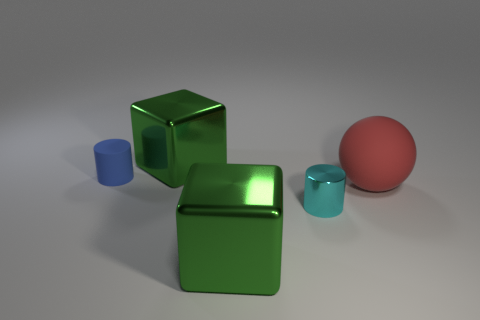Add 4 cyan metal cylinders. How many objects exist? 9 Subtract all cubes. How many objects are left? 3 Add 3 red spheres. How many red spheres exist? 4 Subtract 0 gray blocks. How many objects are left? 5 Subtract all green blocks. Subtract all cyan cylinders. How many objects are left? 2 Add 2 matte objects. How many matte objects are left? 4 